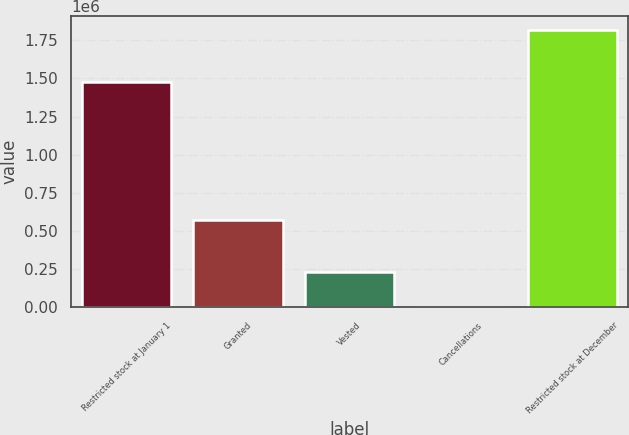<chart> <loc_0><loc_0><loc_500><loc_500><bar_chart><fcel>Restricted stock at January 1<fcel>Granted<fcel>Vested<fcel>Cancellations<fcel>Restricted stock at December<nl><fcel>1.478e+06<fcel>575694<fcel>229979<fcel>5970<fcel>1.81774e+06<nl></chart> 